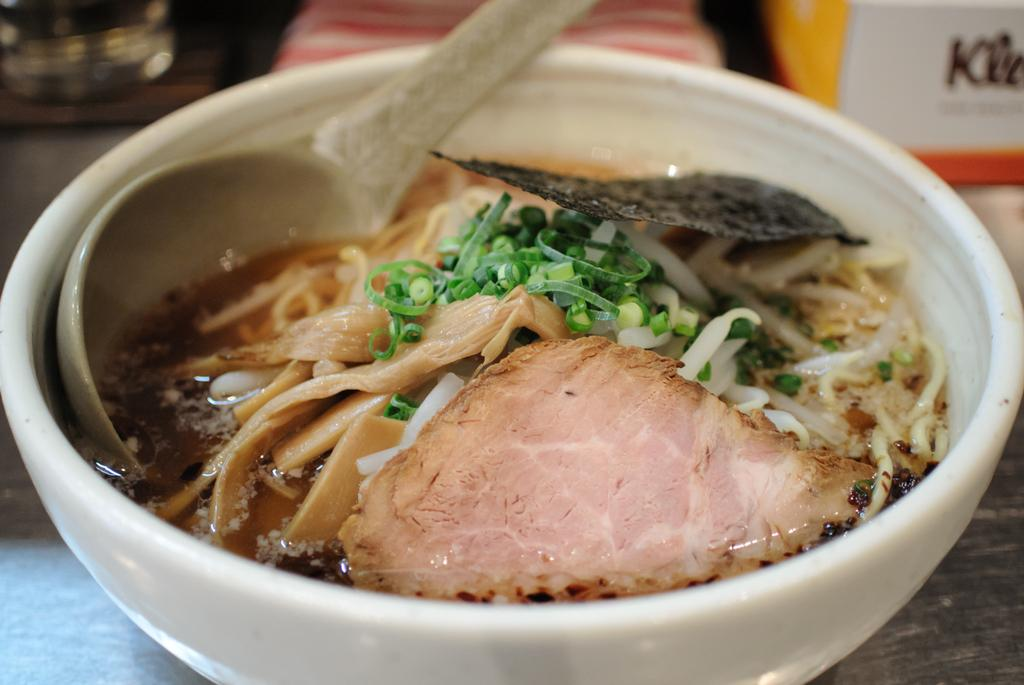What is present in the image related to eating? There is food and a spoon in the image. How are the food and spoon arranged in the image? The food and spoon are in a bowl. What is the color of the surface the bowl is placed on? The surface is black in color. Can you describe the background of the image? The background of the image is blurred. Is the honey dripping from the spoon onto the person's chin in the image? There is no honey or person's chin present in the image. 